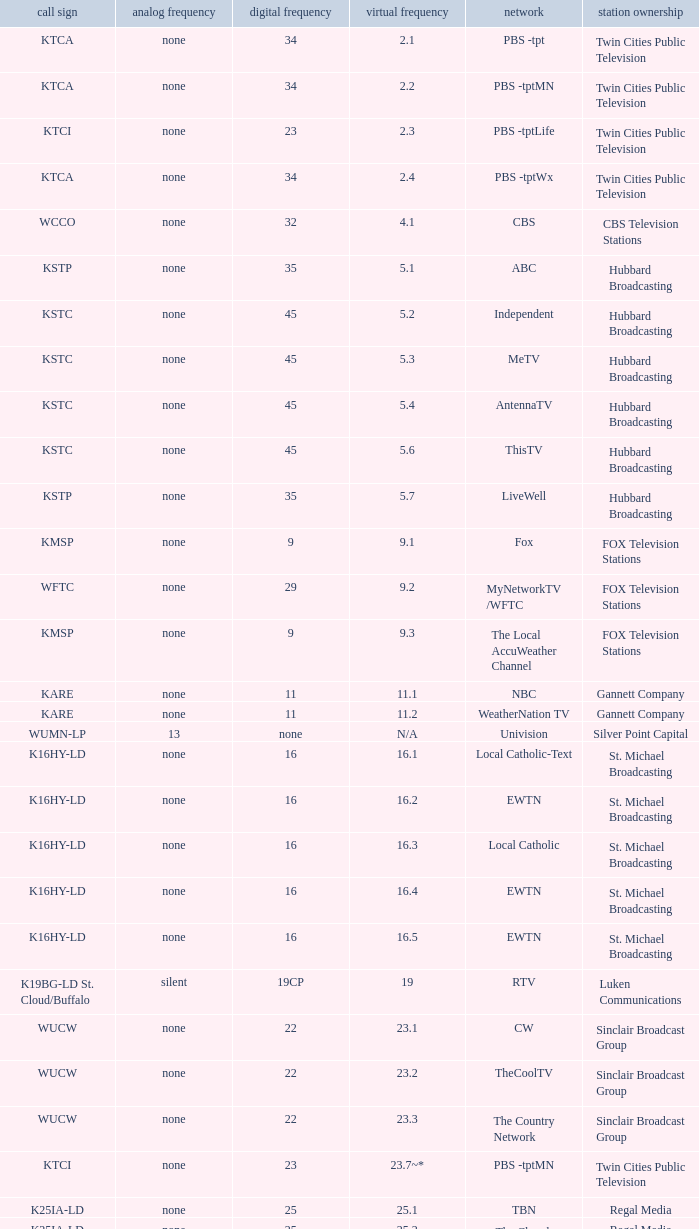Digital channel of 32 belongs to what analog channel? None. 